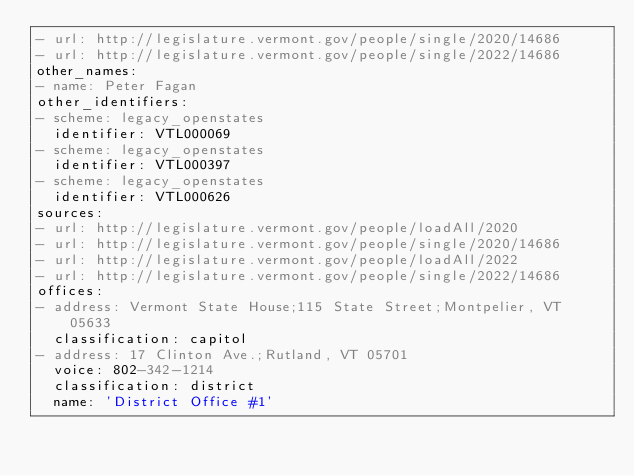Convert code to text. <code><loc_0><loc_0><loc_500><loc_500><_YAML_>- url: http://legislature.vermont.gov/people/single/2020/14686
- url: http://legislature.vermont.gov/people/single/2022/14686
other_names:
- name: Peter Fagan
other_identifiers:
- scheme: legacy_openstates
  identifier: VTL000069
- scheme: legacy_openstates
  identifier: VTL000397
- scheme: legacy_openstates
  identifier: VTL000626
sources:
- url: http://legislature.vermont.gov/people/loadAll/2020
- url: http://legislature.vermont.gov/people/single/2020/14686
- url: http://legislature.vermont.gov/people/loadAll/2022
- url: http://legislature.vermont.gov/people/single/2022/14686
offices:
- address: Vermont State House;115 State Street;Montpelier, VT 05633
  classification: capitol
- address: 17 Clinton Ave.;Rutland, VT 05701
  voice: 802-342-1214
  classification: district
  name: 'District Office #1'
</code> 